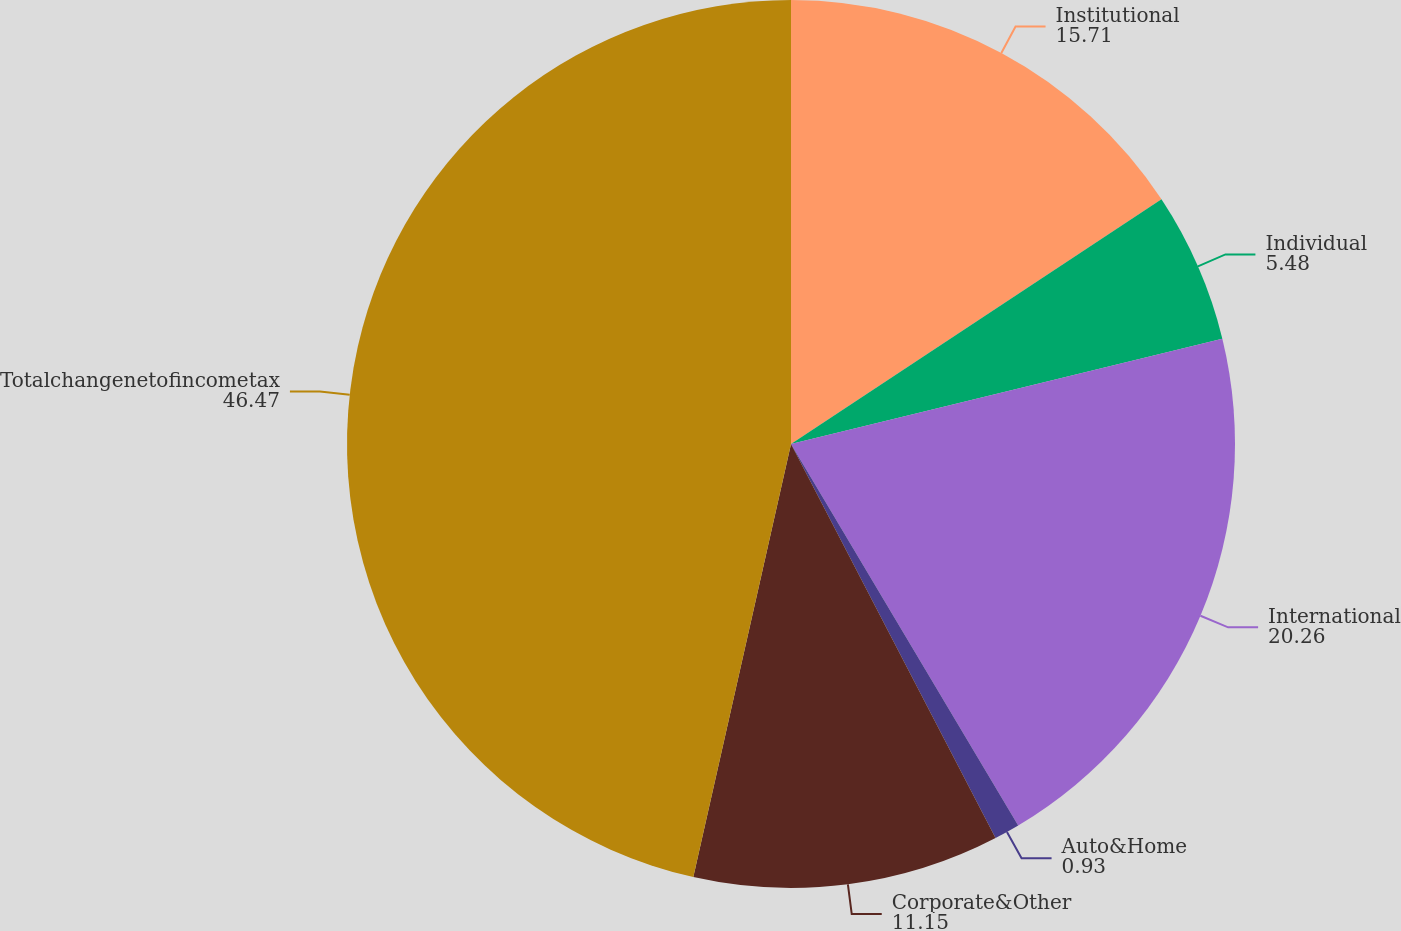Convert chart. <chart><loc_0><loc_0><loc_500><loc_500><pie_chart><fcel>Institutional<fcel>Individual<fcel>International<fcel>Auto&Home<fcel>Corporate&Other<fcel>Totalchangenetofincometax<nl><fcel>15.71%<fcel>5.48%<fcel>20.26%<fcel>0.93%<fcel>11.15%<fcel>46.47%<nl></chart> 